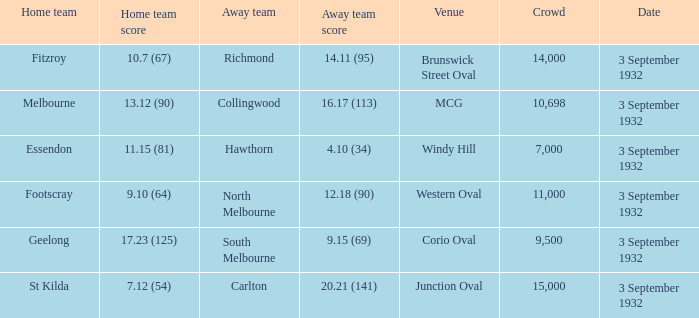What is the total Crowd number for the team that has an Away team score of 12.18 (90)? 11000.0. 